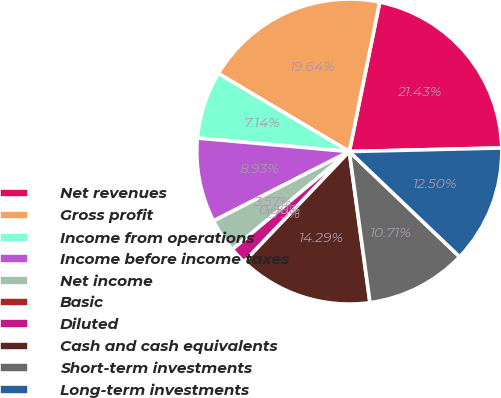Convert chart to OTSL. <chart><loc_0><loc_0><loc_500><loc_500><pie_chart><fcel>Net revenues<fcel>Gross profit<fcel>Income from operations<fcel>Income before income taxes<fcel>Net income<fcel>Basic<fcel>Diluted<fcel>Cash and cash equivalents<fcel>Short-term investments<fcel>Long-term investments<nl><fcel>21.43%<fcel>19.64%<fcel>7.14%<fcel>8.93%<fcel>3.57%<fcel>0.0%<fcel>1.79%<fcel>14.29%<fcel>10.71%<fcel>12.5%<nl></chart> 